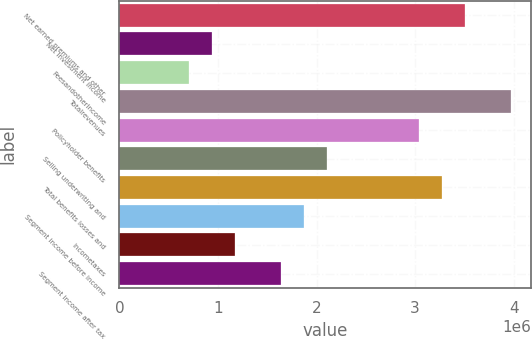<chart> <loc_0><loc_0><loc_500><loc_500><bar_chart><fcel>Net earned premiums and other<fcel>Net investment income<fcel>Feesandotherincome<fcel>Totalrevenues<fcel>Policyholder benefits<fcel>Selling underwriting and<fcel>Total benefits losses and<fcel>Segment income before income<fcel>Incometaxes<fcel>Segment income after tax<nl><fcel>3.50685e+06<fcel>935181<fcel>701393<fcel>3.97442e+06<fcel>3.03927e+06<fcel>2.10412e+06<fcel>3.27306e+06<fcel>1.87033e+06<fcel>1.16897e+06<fcel>1.63654e+06<nl></chart> 